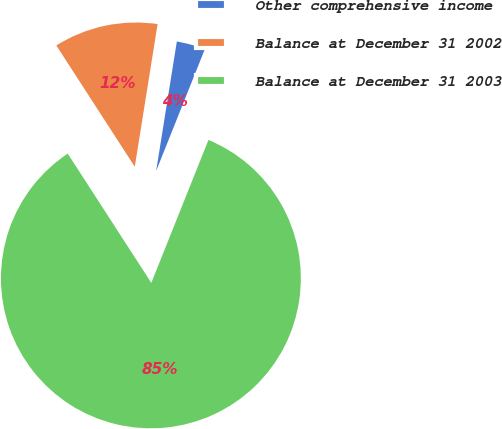Convert chart. <chart><loc_0><loc_0><loc_500><loc_500><pie_chart><fcel>Other comprehensive income<fcel>Balance at December 31 2002<fcel>Balance at December 31 2003<nl><fcel>3.53%<fcel>11.66%<fcel>84.81%<nl></chart> 